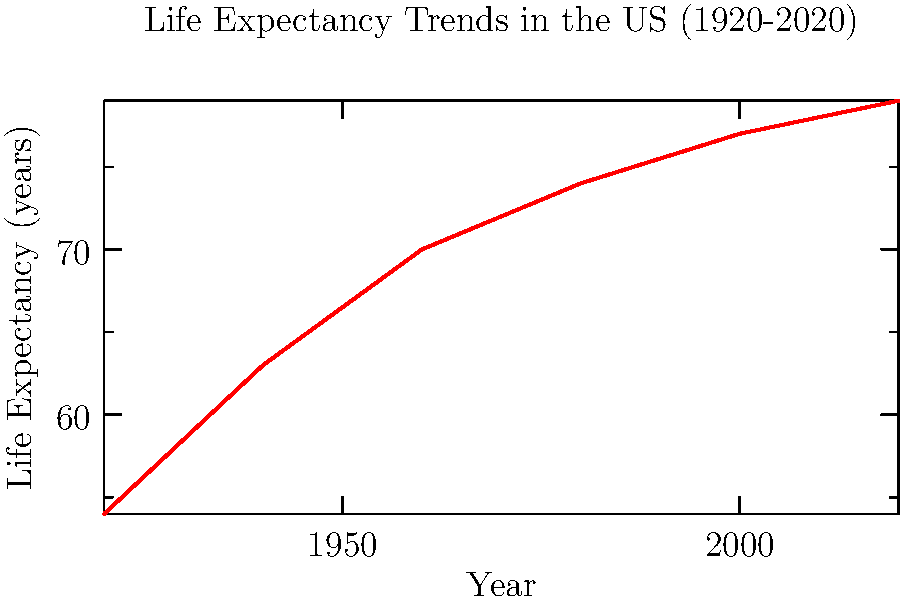Based on the life expectancy trend shown in the graph, which decade saw the most significant increase in life expectancy in the United States? To determine the decade with the most significant increase in life expectancy, we need to calculate the change for each 20-year period and compare:

1. 1920 to 1940: $63 - 54 = 9$ years increase
2. 1940 to 1960: $70 - 63 = 7$ years increase
3. 1960 to 1980: $74 - 70 = 4$ years increase
4. 1980 to 2000: $77 - 74 = 3$ years increase
5. 2000 to 2020: $79 - 77 = 2$ years increase

The largest increase occurred between 1920 and 1940, with a 9-year improvement in life expectancy. This period covers the decades of the 1920s and 1930s.
Answer: 1920s-1930s 